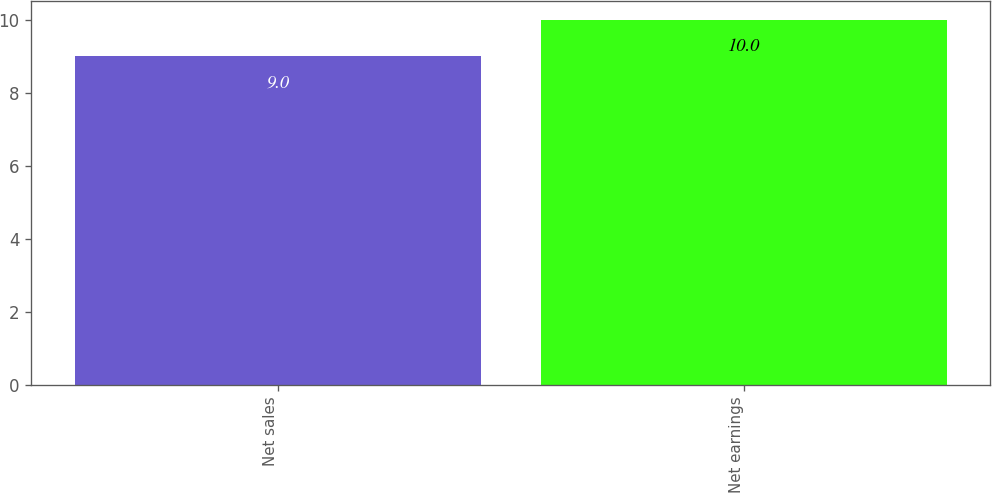<chart> <loc_0><loc_0><loc_500><loc_500><bar_chart><fcel>Net sales<fcel>Net earnings<nl><fcel>9<fcel>10<nl></chart> 